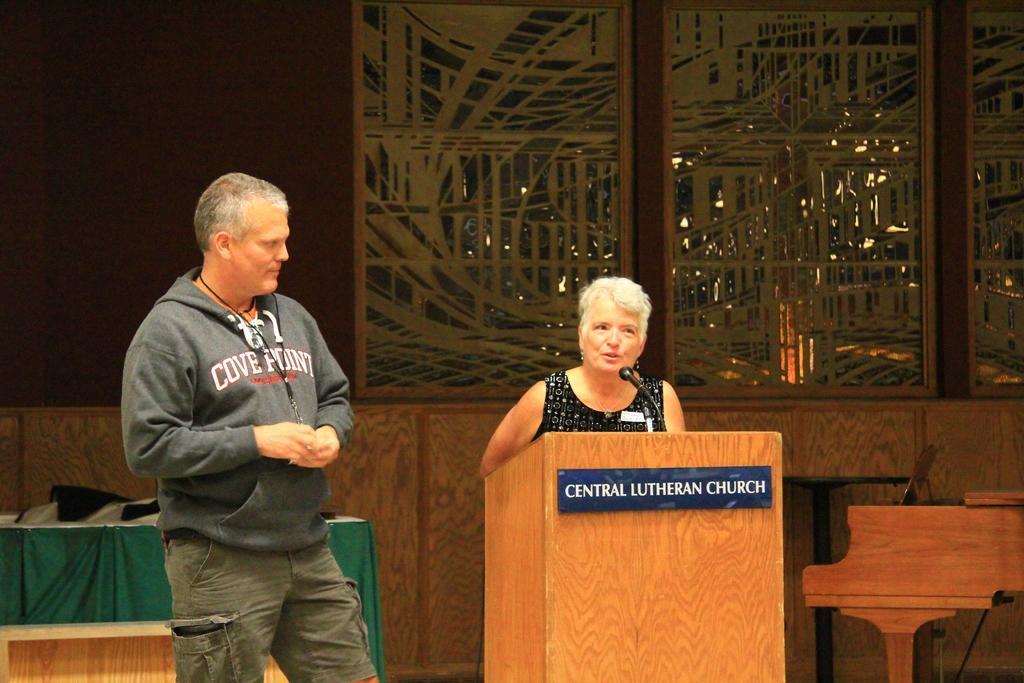In one or two sentences, can you explain what this image depicts? In this picture we can see a man standing and beside him we can see a woman, podium with a mic, name board on it and in the background we can see tables, clothes, wall and some objects. 